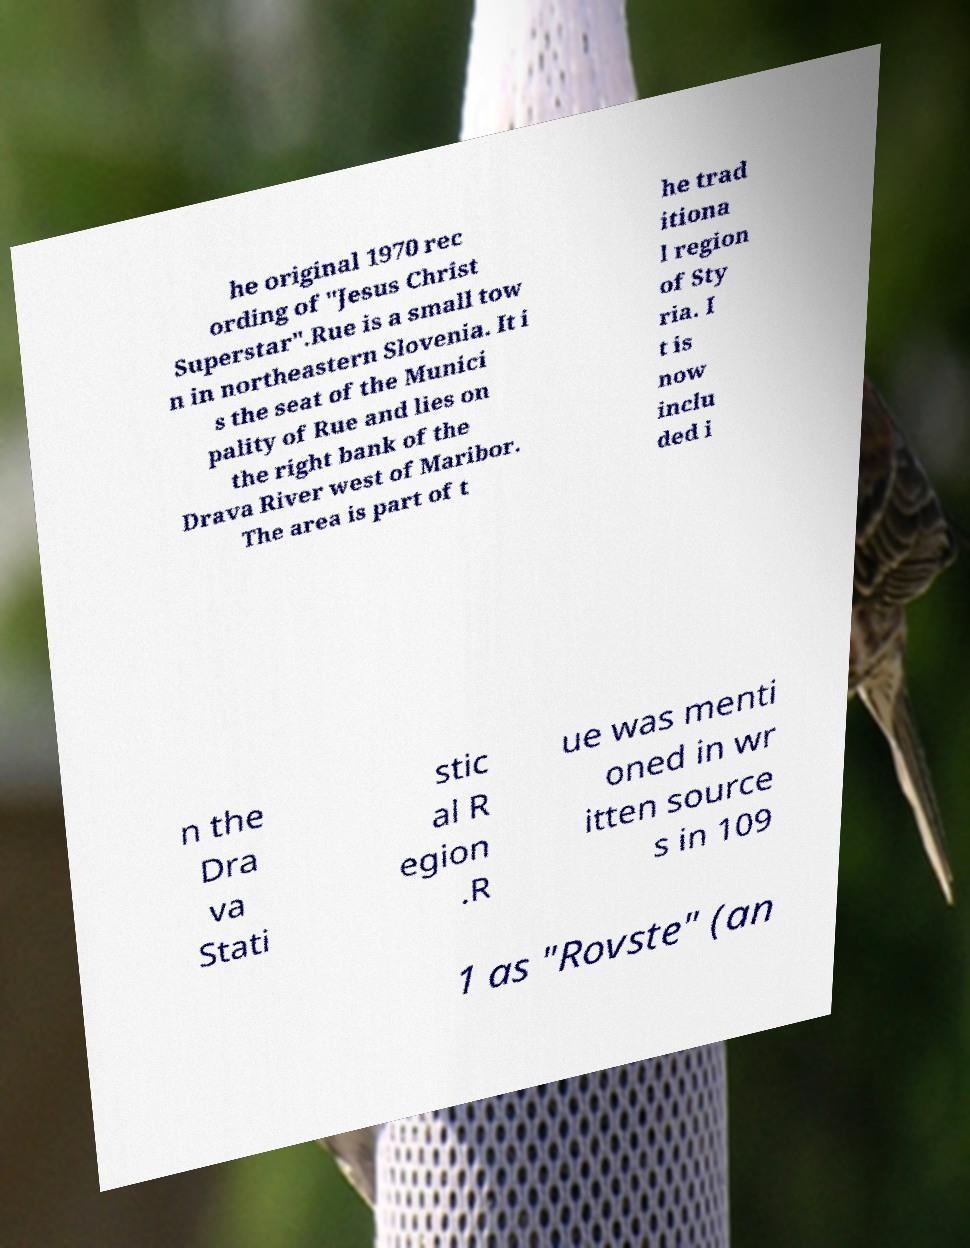There's text embedded in this image that I need extracted. Can you transcribe it verbatim? he original 1970 rec ording of "Jesus Christ Superstar".Rue is a small tow n in northeastern Slovenia. It i s the seat of the Munici pality of Rue and lies on the right bank of the Drava River west of Maribor. The area is part of t he trad itiona l region of Sty ria. I t is now inclu ded i n the Dra va Stati stic al R egion .R ue was menti oned in wr itten source s in 109 1 as "Rovste" (an 